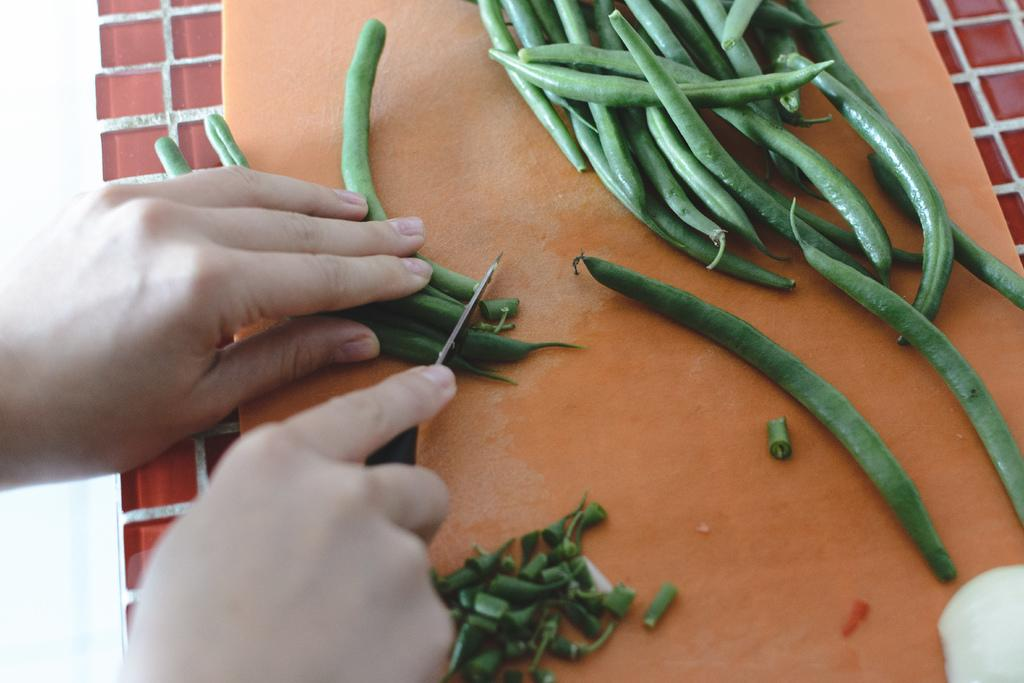What is the person holding in the image? The person is holding a knife in the image. What can be seen on the platform in the image? There are green beans on a platform in the image. What type of oil can be seen dripping from the cows in the image? There are no cows present in the image, and therefore no oil dripping from them. 